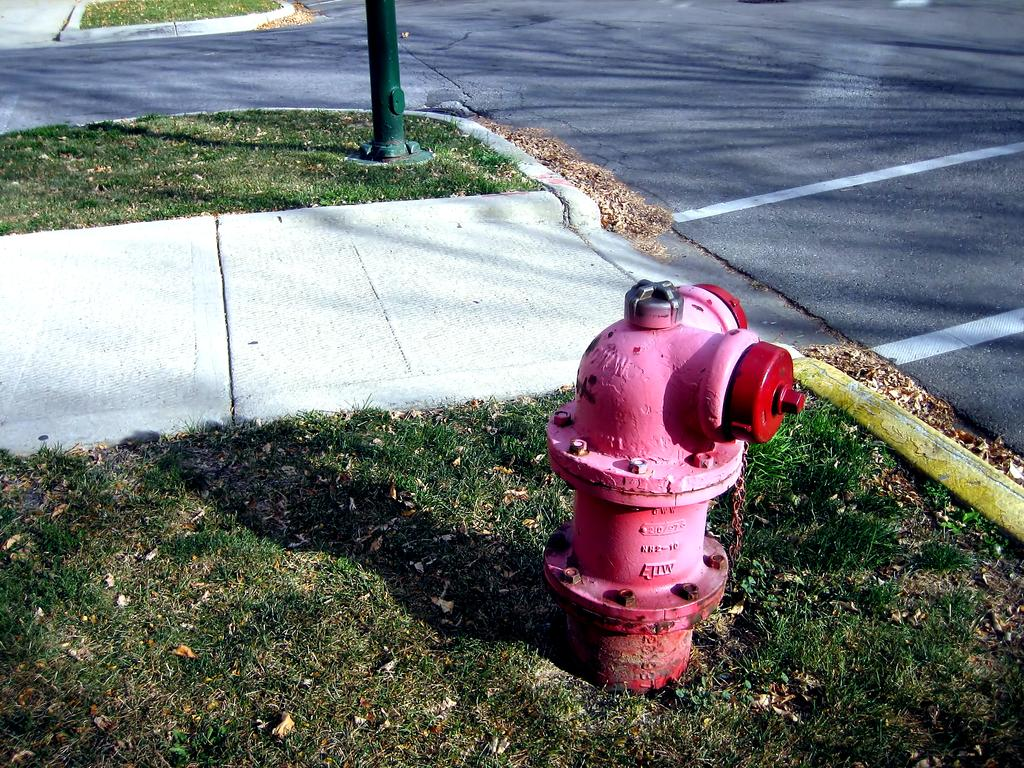What color is the fire hydrant in the image? The fire hydrant is red in the image. What is the fire hydrant placed on? The fire hydrant is on a greenery ground. What other colorful object can be seen in the background of the image? There is a green color pole in the background of the image. What type of environment might this image depict? The image might depict an outdoor environment, given the presence of a greenery ground. What month is it in the image? The image does not provide any information about the month or time of year. Can you see a hook attached to the fire hydrant in the image? There is no hook visible on the fire hydrant in the image. 